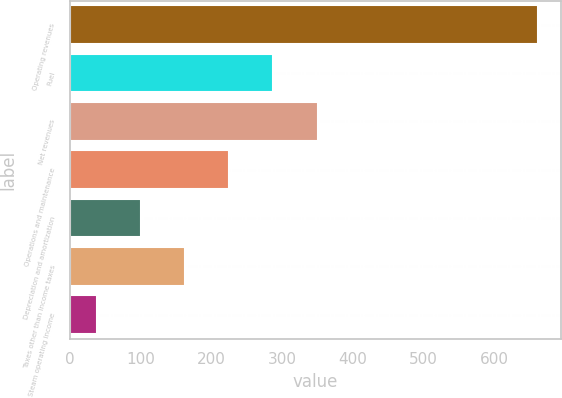Convert chart to OTSL. <chart><loc_0><loc_0><loc_500><loc_500><bar_chart><fcel>Operating revenues<fcel>Fuel<fcel>Net revenues<fcel>Operations and maintenance<fcel>Depreciation and amortization<fcel>Taxes other than income taxes<fcel>Steam operating income<nl><fcel>661<fcel>287.8<fcel>351<fcel>225.6<fcel>101.2<fcel>163.4<fcel>39<nl></chart> 